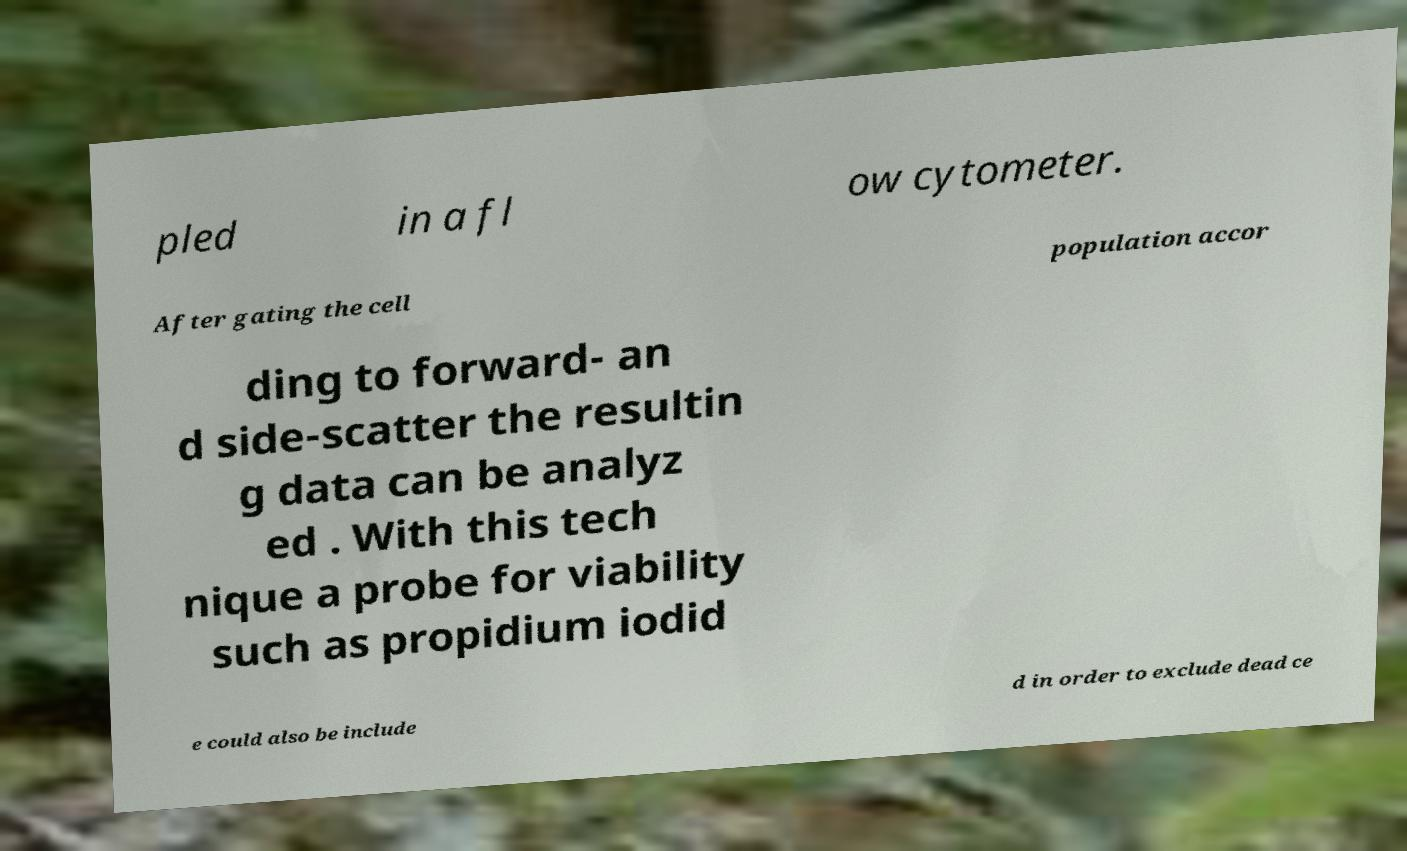Could you assist in decoding the text presented in this image and type it out clearly? pled in a fl ow cytometer. After gating the cell population accor ding to forward- an d side-scatter the resultin g data can be analyz ed . With this tech nique a probe for viability such as propidium iodid e could also be include d in order to exclude dead ce 